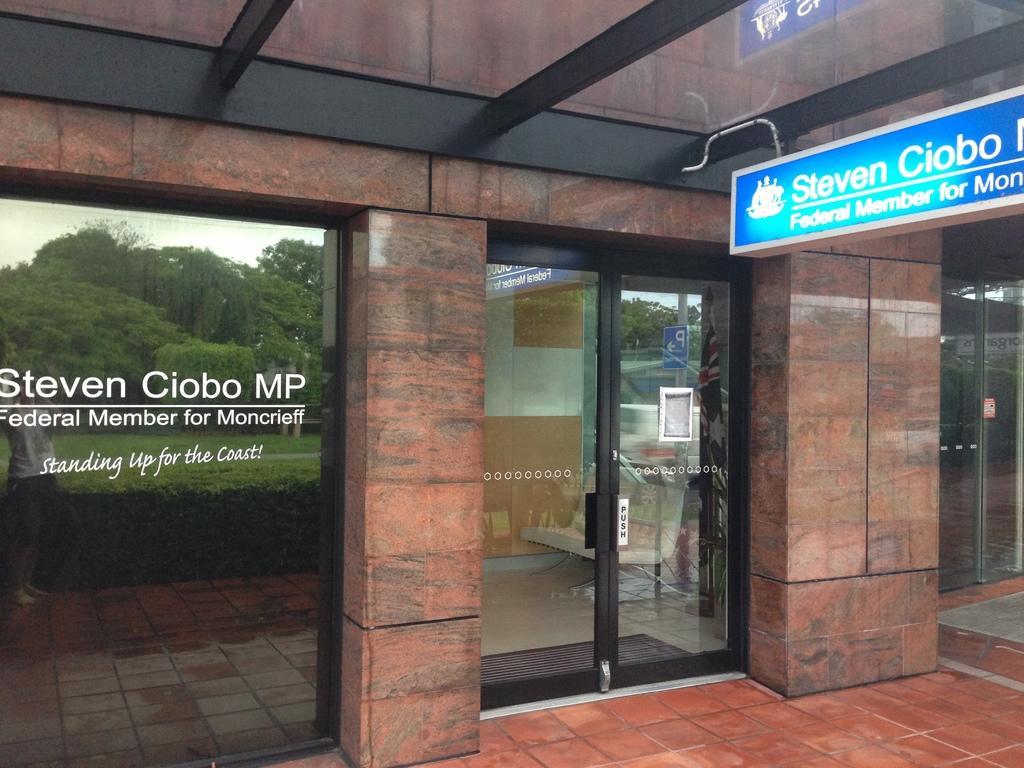Can you describe this image briefly? In this image I can see a door and glass wall. Here I can see a board which has something written on it. I can also see something written on the glass wall. Here I can see trees and the sky. 